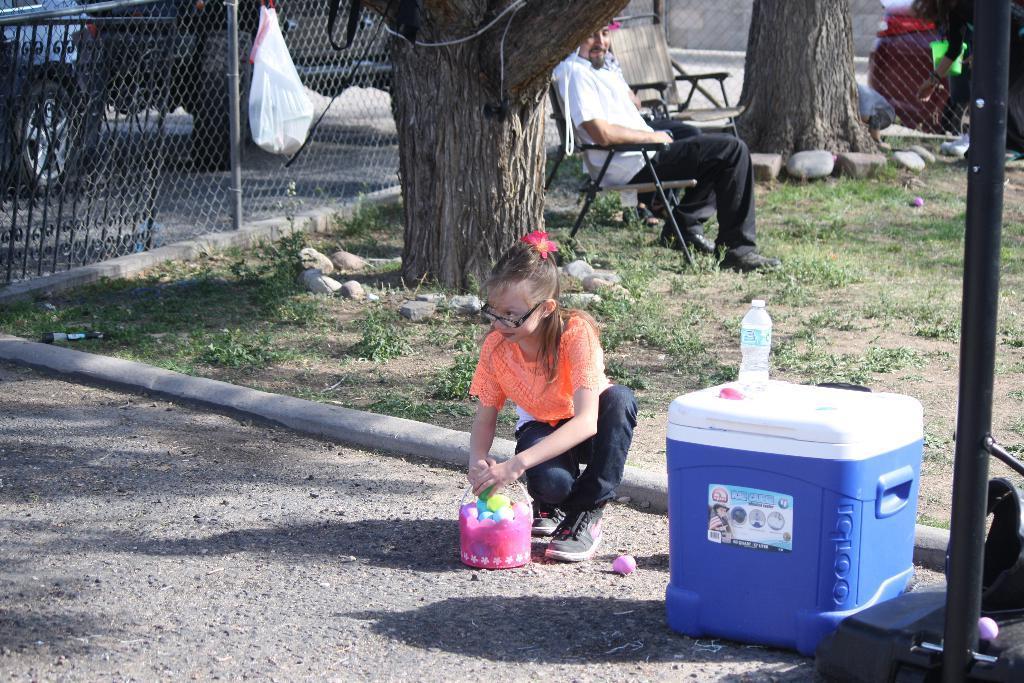Can you describe this image briefly? In this picture there is a girl sitting on the road in front of a basket. There is a box beside her on which a water bottle was placed. In the background there is a man sitting in the chair. Behind him there is a tree. We can observe a fence in the left side behind which some vehicle is going. 